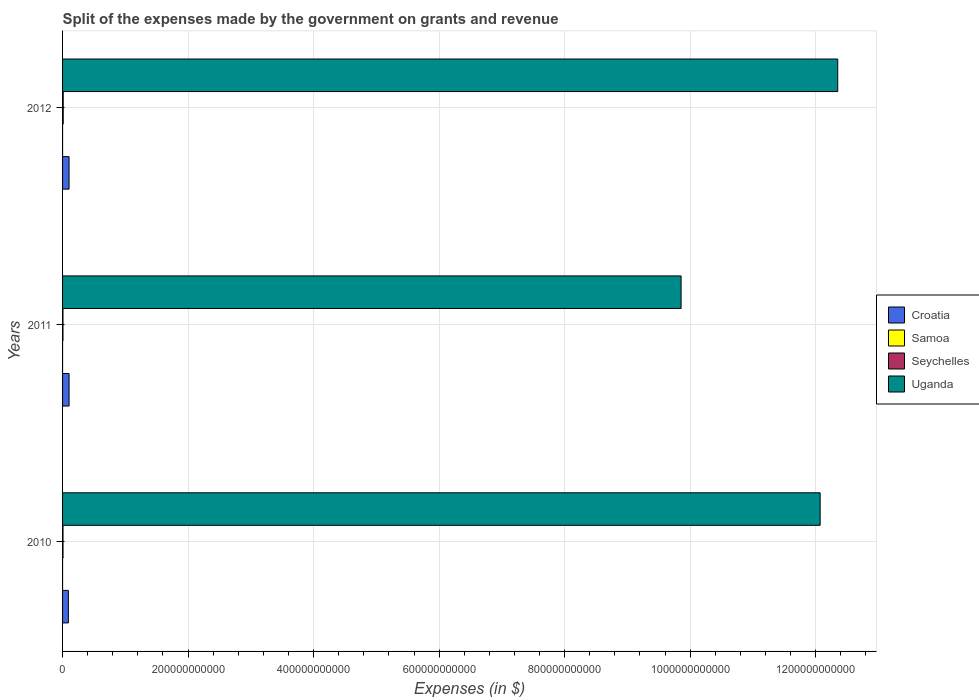Are the number of bars per tick equal to the number of legend labels?
Offer a very short reply. Yes. How many bars are there on the 3rd tick from the top?
Provide a succinct answer. 4. What is the label of the 3rd group of bars from the top?
Offer a very short reply. 2010. What is the expenses made by the government on grants and revenue in Seychelles in 2010?
Make the answer very short. 7.08e+08. Across all years, what is the maximum expenses made by the government on grants and revenue in Uganda?
Give a very brief answer. 1.24e+12. Across all years, what is the minimum expenses made by the government on grants and revenue in Seychelles?
Keep it short and to the point. 6.70e+08. In which year was the expenses made by the government on grants and revenue in Samoa minimum?
Keep it short and to the point. 2010. What is the total expenses made by the government on grants and revenue in Samoa in the graph?
Keep it short and to the point. 2.32e+05. What is the difference between the expenses made by the government on grants and revenue in Samoa in 2010 and that in 2011?
Make the answer very short. -2.44e+04. What is the difference between the expenses made by the government on grants and revenue in Seychelles in 2010 and the expenses made by the government on grants and revenue in Croatia in 2012?
Give a very brief answer. -9.64e+09. What is the average expenses made by the government on grants and revenue in Samoa per year?
Provide a short and direct response. 7.72e+04. In the year 2011, what is the difference between the expenses made by the government on grants and revenue in Croatia and expenses made by the government on grants and revenue in Uganda?
Your answer should be compact. -9.75e+11. What is the ratio of the expenses made by the government on grants and revenue in Samoa in 2010 to that in 2012?
Give a very brief answer. 0.65. What is the difference between the highest and the second highest expenses made by the government on grants and revenue in Samoa?
Your response must be concise. 6851.45. What is the difference between the highest and the lowest expenses made by the government on grants and revenue in Seychelles?
Give a very brief answer. 3.59e+08. Is the sum of the expenses made by the government on grants and revenue in Seychelles in 2010 and 2011 greater than the maximum expenses made by the government on grants and revenue in Samoa across all years?
Keep it short and to the point. Yes. Is it the case that in every year, the sum of the expenses made by the government on grants and revenue in Croatia and expenses made by the government on grants and revenue in Uganda is greater than the sum of expenses made by the government on grants and revenue in Samoa and expenses made by the government on grants and revenue in Seychelles?
Your response must be concise. No. What does the 3rd bar from the top in 2010 represents?
Provide a succinct answer. Samoa. What does the 3rd bar from the bottom in 2011 represents?
Keep it short and to the point. Seychelles. How many years are there in the graph?
Make the answer very short. 3. What is the difference between two consecutive major ticks on the X-axis?
Your response must be concise. 2.00e+11. Are the values on the major ticks of X-axis written in scientific E-notation?
Your response must be concise. No. How are the legend labels stacked?
Keep it short and to the point. Vertical. What is the title of the graph?
Make the answer very short. Split of the expenses made by the government on grants and revenue. Does "Dominica" appear as one of the legend labels in the graph?
Ensure brevity in your answer.  No. What is the label or title of the X-axis?
Offer a terse response. Expenses (in $). What is the label or title of the Y-axis?
Offer a terse response. Years. What is the Expenses (in $) of Croatia in 2010?
Offer a terse response. 9.26e+09. What is the Expenses (in $) in Samoa in 2010?
Offer a very short reply. 5.86e+04. What is the Expenses (in $) of Seychelles in 2010?
Ensure brevity in your answer.  7.08e+08. What is the Expenses (in $) of Uganda in 2010?
Offer a terse response. 1.21e+12. What is the Expenses (in $) in Croatia in 2011?
Your answer should be compact. 1.04e+1. What is the Expenses (in $) in Samoa in 2011?
Make the answer very short. 8.31e+04. What is the Expenses (in $) of Seychelles in 2011?
Ensure brevity in your answer.  6.70e+08. What is the Expenses (in $) of Uganda in 2011?
Provide a short and direct response. 9.86e+11. What is the Expenses (in $) of Croatia in 2012?
Provide a short and direct response. 1.03e+1. What is the Expenses (in $) of Samoa in 2012?
Your response must be concise. 8.99e+04. What is the Expenses (in $) of Seychelles in 2012?
Ensure brevity in your answer.  1.03e+09. What is the Expenses (in $) of Uganda in 2012?
Keep it short and to the point. 1.24e+12. Across all years, what is the maximum Expenses (in $) of Croatia?
Your answer should be compact. 1.04e+1. Across all years, what is the maximum Expenses (in $) in Samoa?
Make the answer very short. 8.99e+04. Across all years, what is the maximum Expenses (in $) of Seychelles?
Provide a short and direct response. 1.03e+09. Across all years, what is the maximum Expenses (in $) of Uganda?
Offer a terse response. 1.24e+12. Across all years, what is the minimum Expenses (in $) of Croatia?
Your answer should be very brief. 9.26e+09. Across all years, what is the minimum Expenses (in $) of Samoa?
Provide a succinct answer. 5.86e+04. Across all years, what is the minimum Expenses (in $) of Seychelles?
Ensure brevity in your answer.  6.70e+08. Across all years, what is the minimum Expenses (in $) in Uganda?
Your response must be concise. 9.86e+11. What is the total Expenses (in $) of Croatia in the graph?
Your answer should be very brief. 3.00e+1. What is the total Expenses (in $) of Samoa in the graph?
Make the answer very short. 2.32e+05. What is the total Expenses (in $) of Seychelles in the graph?
Give a very brief answer. 2.41e+09. What is the total Expenses (in $) of Uganda in the graph?
Provide a short and direct response. 3.43e+12. What is the difference between the Expenses (in $) in Croatia in 2010 and that in 2011?
Ensure brevity in your answer.  -1.12e+09. What is the difference between the Expenses (in $) in Samoa in 2010 and that in 2011?
Your answer should be very brief. -2.44e+04. What is the difference between the Expenses (in $) of Seychelles in 2010 and that in 2011?
Your answer should be compact. 3.82e+07. What is the difference between the Expenses (in $) in Uganda in 2010 and that in 2011?
Your response must be concise. 2.22e+11. What is the difference between the Expenses (in $) of Croatia in 2010 and that in 2012?
Offer a very short reply. -1.08e+09. What is the difference between the Expenses (in $) in Samoa in 2010 and that in 2012?
Offer a terse response. -3.13e+04. What is the difference between the Expenses (in $) of Seychelles in 2010 and that in 2012?
Make the answer very short. -3.20e+08. What is the difference between the Expenses (in $) of Uganda in 2010 and that in 2012?
Give a very brief answer. -2.80e+1. What is the difference between the Expenses (in $) of Croatia in 2011 and that in 2012?
Offer a terse response. 3.52e+07. What is the difference between the Expenses (in $) of Samoa in 2011 and that in 2012?
Offer a very short reply. -6851.45. What is the difference between the Expenses (in $) in Seychelles in 2011 and that in 2012?
Ensure brevity in your answer.  -3.59e+08. What is the difference between the Expenses (in $) of Uganda in 2011 and that in 2012?
Keep it short and to the point. -2.50e+11. What is the difference between the Expenses (in $) of Croatia in 2010 and the Expenses (in $) of Samoa in 2011?
Give a very brief answer. 9.26e+09. What is the difference between the Expenses (in $) of Croatia in 2010 and the Expenses (in $) of Seychelles in 2011?
Ensure brevity in your answer.  8.59e+09. What is the difference between the Expenses (in $) in Croatia in 2010 and the Expenses (in $) in Uganda in 2011?
Ensure brevity in your answer.  -9.76e+11. What is the difference between the Expenses (in $) in Samoa in 2010 and the Expenses (in $) in Seychelles in 2011?
Keep it short and to the point. -6.70e+08. What is the difference between the Expenses (in $) in Samoa in 2010 and the Expenses (in $) in Uganda in 2011?
Provide a short and direct response. -9.86e+11. What is the difference between the Expenses (in $) of Seychelles in 2010 and the Expenses (in $) of Uganda in 2011?
Provide a succinct answer. -9.85e+11. What is the difference between the Expenses (in $) of Croatia in 2010 and the Expenses (in $) of Samoa in 2012?
Ensure brevity in your answer.  9.26e+09. What is the difference between the Expenses (in $) in Croatia in 2010 and the Expenses (in $) in Seychelles in 2012?
Provide a succinct answer. 8.23e+09. What is the difference between the Expenses (in $) of Croatia in 2010 and the Expenses (in $) of Uganda in 2012?
Keep it short and to the point. -1.23e+12. What is the difference between the Expenses (in $) in Samoa in 2010 and the Expenses (in $) in Seychelles in 2012?
Offer a terse response. -1.03e+09. What is the difference between the Expenses (in $) of Samoa in 2010 and the Expenses (in $) of Uganda in 2012?
Keep it short and to the point. -1.24e+12. What is the difference between the Expenses (in $) in Seychelles in 2010 and the Expenses (in $) in Uganda in 2012?
Keep it short and to the point. -1.23e+12. What is the difference between the Expenses (in $) in Croatia in 2011 and the Expenses (in $) in Samoa in 2012?
Provide a short and direct response. 1.04e+1. What is the difference between the Expenses (in $) of Croatia in 2011 and the Expenses (in $) of Seychelles in 2012?
Give a very brief answer. 9.35e+09. What is the difference between the Expenses (in $) in Croatia in 2011 and the Expenses (in $) in Uganda in 2012?
Provide a short and direct response. -1.22e+12. What is the difference between the Expenses (in $) in Samoa in 2011 and the Expenses (in $) in Seychelles in 2012?
Make the answer very short. -1.03e+09. What is the difference between the Expenses (in $) of Samoa in 2011 and the Expenses (in $) of Uganda in 2012?
Your answer should be very brief. -1.24e+12. What is the difference between the Expenses (in $) in Seychelles in 2011 and the Expenses (in $) in Uganda in 2012?
Your answer should be very brief. -1.23e+12. What is the average Expenses (in $) in Croatia per year?
Your answer should be compact. 1.00e+1. What is the average Expenses (in $) of Samoa per year?
Make the answer very short. 7.72e+04. What is the average Expenses (in $) of Seychelles per year?
Your answer should be compact. 8.02e+08. What is the average Expenses (in $) in Uganda per year?
Provide a succinct answer. 1.14e+12. In the year 2010, what is the difference between the Expenses (in $) in Croatia and Expenses (in $) in Samoa?
Keep it short and to the point. 9.26e+09. In the year 2010, what is the difference between the Expenses (in $) of Croatia and Expenses (in $) of Seychelles?
Provide a succinct answer. 8.55e+09. In the year 2010, what is the difference between the Expenses (in $) in Croatia and Expenses (in $) in Uganda?
Give a very brief answer. -1.20e+12. In the year 2010, what is the difference between the Expenses (in $) in Samoa and Expenses (in $) in Seychelles?
Ensure brevity in your answer.  -7.08e+08. In the year 2010, what is the difference between the Expenses (in $) of Samoa and Expenses (in $) of Uganda?
Offer a very short reply. -1.21e+12. In the year 2010, what is the difference between the Expenses (in $) of Seychelles and Expenses (in $) of Uganda?
Your answer should be compact. -1.21e+12. In the year 2011, what is the difference between the Expenses (in $) of Croatia and Expenses (in $) of Samoa?
Your response must be concise. 1.04e+1. In the year 2011, what is the difference between the Expenses (in $) in Croatia and Expenses (in $) in Seychelles?
Provide a succinct answer. 9.71e+09. In the year 2011, what is the difference between the Expenses (in $) of Croatia and Expenses (in $) of Uganda?
Make the answer very short. -9.75e+11. In the year 2011, what is the difference between the Expenses (in $) of Samoa and Expenses (in $) of Seychelles?
Your answer should be very brief. -6.70e+08. In the year 2011, what is the difference between the Expenses (in $) in Samoa and Expenses (in $) in Uganda?
Your answer should be very brief. -9.86e+11. In the year 2011, what is the difference between the Expenses (in $) of Seychelles and Expenses (in $) of Uganda?
Keep it short and to the point. -9.85e+11. In the year 2012, what is the difference between the Expenses (in $) in Croatia and Expenses (in $) in Samoa?
Ensure brevity in your answer.  1.03e+1. In the year 2012, what is the difference between the Expenses (in $) in Croatia and Expenses (in $) in Seychelles?
Your answer should be compact. 9.32e+09. In the year 2012, what is the difference between the Expenses (in $) of Croatia and Expenses (in $) of Uganda?
Your response must be concise. -1.22e+12. In the year 2012, what is the difference between the Expenses (in $) in Samoa and Expenses (in $) in Seychelles?
Keep it short and to the point. -1.03e+09. In the year 2012, what is the difference between the Expenses (in $) in Samoa and Expenses (in $) in Uganda?
Your answer should be very brief. -1.24e+12. In the year 2012, what is the difference between the Expenses (in $) in Seychelles and Expenses (in $) in Uganda?
Make the answer very short. -1.23e+12. What is the ratio of the Expenses (in $) in Croatia in 2010 to that in 2011?
Offer a terse response. 0.89. What is the ratio of the Expenses (in $) in Samoa in 2010 to that in 2011?
Provide a succinct answer. 0.71. What is the ratio of the Expenses (in $) of Seychelles in 2010 to that in 2011?
Your response must be concise. 1.06. What is the ratio of the Expenses (in $) in Uganda in 2010 to that in 2011?
Make the answer very short. 1.22. What is the ratio of the Expenses (in $) in Croatia in 2010 to that in 2012?
Your answer should be very brief. 0.9. What is the ratio of the Expenses (in $) in Samoa in 2010 to that in 2012?
Offer a terse response. 0.65. What is the ratio of the Expenses (in $) of Seychelles in 2010 to that in 2012?
Your response must be concise. 0.69. What is the ratio of the Expenses (in $) of Uganda in 2010 to that in 2012?
Your response must be concise. 0.98. What is the ratio of the Expenses (in $) in Samoa in 2011 to that in 2012?
Your answer should be very brief. 0.92. What is the ratio of the Expenses (in $) in Seychelles in 2011 to that in 2012?
Offer a very short reply. 0.65. What is the ratio of the Expenses (in $) in Uganda in 2011 to that in 2012?
Give a very brief answer. 0.8. What is the difference between the highest and the second highest Expenses (in $) of Croatia?
Give a very brief answer. 3.52e+07. What is the difference between the highest and the second highest Expenses (in $) of Samoa?
Your response must be concise. 6851.45. What is the difference between the highest and the second highest Expenses (in $) in Seychelles?
Offer a very short reply. 3.20e+08. What is the difference between the highest and the second highest Expenses (in $) of Uganda?
Your answer should be compact. 2.80e+1. What is the difference between the highest and the lowest Expenses (in $) of Croatia?
Make the answer very short. 1.12e+09. What is the difference between the highest and the lowest Expenses (in $) in Samoa?
Ensure brevity in your answer.  3.13e+04. What is the difference between the highest and the lowest Expenses (in $) in Seychelles?
Provide a succinct answer. 3.59e+08. What is the difference between the highest and the lowest Expenses (in $) of Uganda?
Offer a very short reply. 2.50e+11. 